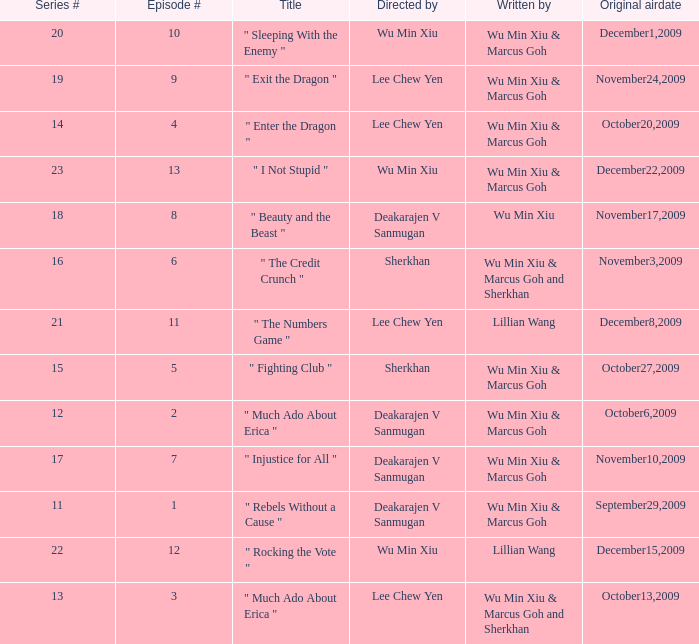What is the episode number for series 17? 7.0. 